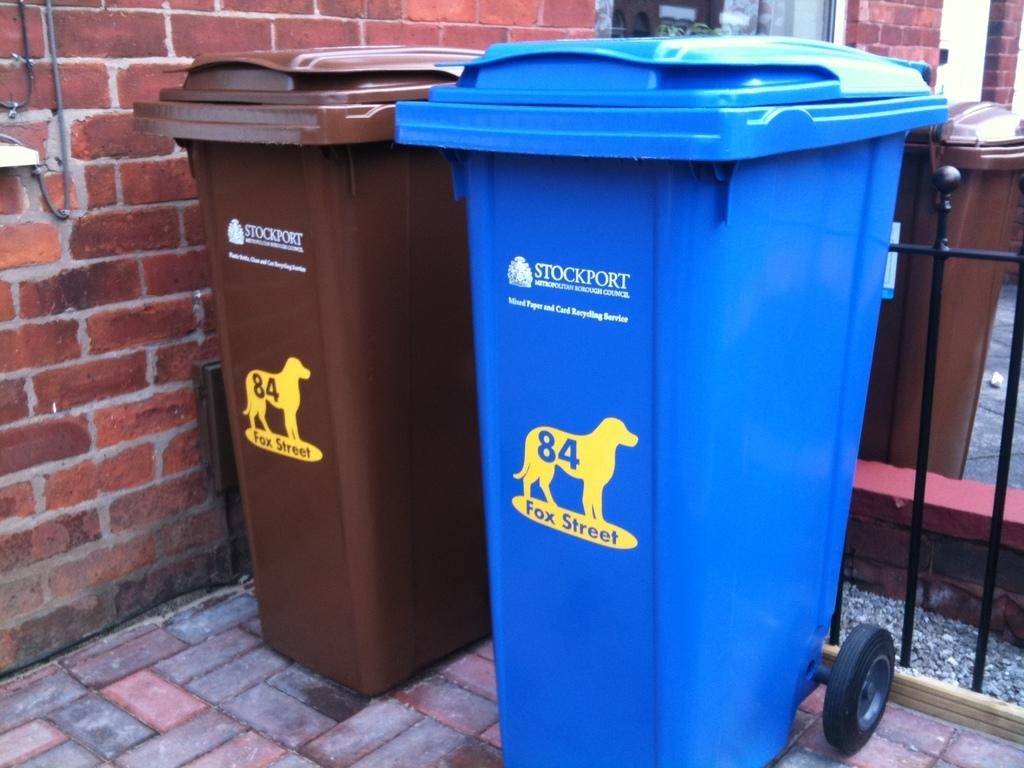<image>
Provide a brief description of the given image. two trash cans, one blue one brown, with a 84 fox street decal 